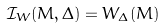Convert formula to latex. <formula><loc_0><loc_0><loc_500><loc_500>\mathcal { I } _ { W } ( M , \Delta ) = W _ { \Delta } ( M )</formula> 